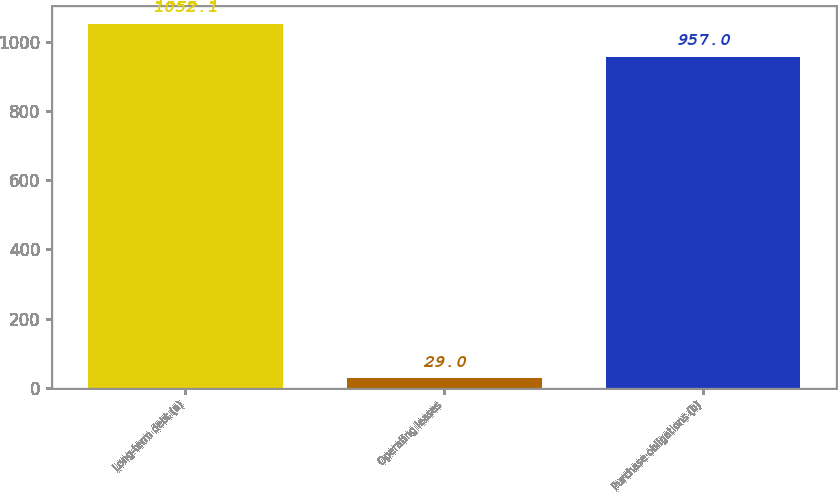<chart> <loc_0><loc_0><loc_500><loc_500><bar_chart><fcel>Long-term debt (a)<fcel>Operating leases<fcel>Purchase obligations (b)<nl><fcel>1052.1<fcel>29<fcel>957<nl></chart> 